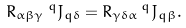<formula> <loc_0><loc_0><loc_500><loc_500>R _ { \alpha \beta \gamma } \, ^ { q } J _ { q \delta } = R _ { \gamma \delta \alpha } \, ^ { q } J _ { q \beta } .</formula> 